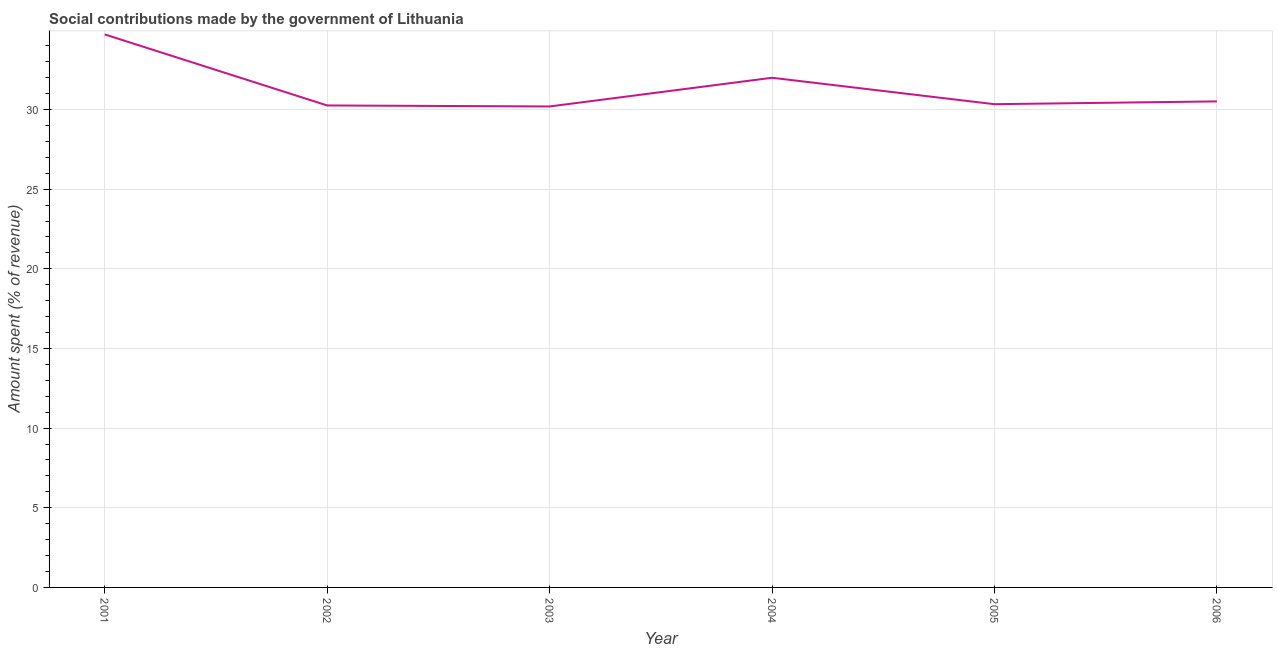What is the amount spent in making social contributions in 2001?
Ensure brevity in your answer.  34.71. Across all years, what is the maximum amount spent in making social contributions?
Ensure brevity in your answer.  34.71. Across all years, what is the minimum amount spent in making social contributions?
Make the answer very short. 30.19. In which year was the amount spent in making social contributions maximum?
Your answer should be compact. 2001. In which year was the amount spent in making social contributions minimum?
Give a very brief answer. 2003. What is the sum of the amount spent in making social contributions?
Offer a very short reply. 187.99. What is the difference between the amount spent in making social contributions in 2003 and 2005?
Offer a terse response. -0.14. What is the average amount spent in making social contributions per year?
Your response must be concise. 31.33. What is the median amount spent in making social contributions?
Provide a succinct answer. 30.42. In how many years, is the amount spent in making social contributions greater than 22 %?
Offer a very short reply. 6. What is the ratio of the amount spent in making social contributions in 2001 to that in 2003?
Keep it short and to the point. 1.15. What is the difference between the highest and the second highest amount spent in making social contributions?
Ensure brevity in your answer.  2.72. Is the sum of the amount spent in making social contributions in 2002 and 2006 greater than the maximum amount spent in making social contributions across all years?
Your answer should be compact. Yes. What is the difference between the highest and the lowest amount spent in making social contributions?
Make the answer very short. 4.52. How many lines are there?
Offer a terse response. 1. How many years are there in the graph?
Provide a succinct answer. 6. Are the values on the major ticks of Y-axis written in scientific E-notation?
Keep it short and to the point. No. Does the graph contain any zero values?
Offer a very short reply. No. Does the graph contain grids?
Your answer should be very brief. Yes. What is the title of the graph?
Provide a succinct answer. Social contributions made by the government of Lithuania. What is the label or title of the Y-axis?
Your answer should be compact. Amount spent (% of revenue). What is the Amount spent (% of revenue) in 2001?
Make the answer very short. 34.71. What is the Amount spent (% of revenue) of 2002?
Provide a succinct answer. 30.25. What is the Amount spent (% of revenue) of 2003?
Offer a terse response. 30.19. What is the Amount spent (% of revenue) of 2004?
Make the answer very short. 31.99. What is the Amount spent (% of revenue) of 2005?
Your response must be concise. 30.33. What is the Amount spent (% of revenue) in 2006?
Make the answer very short. 30.51. What is the difference between the Amount spent (% of revenue) in 2001 and 2002?
Provide a short and direct response. 4.46. What is the difference between the Amount spent (% of revenue) in 2001 and 2003?
Your response must be concise. 4.52. What is the difference between the Amount spent (% of revenue) in 2001 and 2004?
Keep it short and to the point. 2.72. What is the difference between the Amount spent (% of revenue) in 2001 and 2005?
Offer a very short reply. 4.38. What is the difference between the Amount spent (% of revenue) in 2001 and 2006?
Provide a short and direct response. 4.2. What is the difference between the Amount spent (% of revenue) in 2002 and 2003?
Offer a terse response. 0.06. What is the difference between the Amount spent (% of revenue) in 2002 and 2004?
Make the answer very short. -1.74. What is the difference between the Amount spent (% of revenue) in 2002 and 2005?
Offer a very short reply. -0.08. What is the difference between the Amount spent (% of revenue) in 2002 and 2006?
Ensure brevity in your answer.  -0.25. What is the difference between the Amount spent (% of revenue) in 2003 and 2004?
Your answer should be very brief. -1.8. What is the difference between the Amount spent (% of revenue) in 2003 and 2005?
Offer a very short reply. -0.14. What is the difference between the Amount spent (% of revenue) in 2003 and 2006?
Give a very brief answer. -0.32. What is the difference between the Amount spent (% of revenue) in 2004 and 2005?
Offer a very short reply. 1.66. What is the difference between the Amount spent (% of revenue) in 2004 and 2006?
Provide a short and direct response. 1.48. What is the difference between the Amount spent (% of revenue) in 2005 and 2006?
Your answer should be compact. -0.18. What is the ratio of the Amount spent (% of revenue) in 2001 to that in 2002?
Your response must be concise. 1.15. What is the ratio of the Amount spent (% of revenue) in 2001 to that in 2003?
Give a very brief answer. 1.15. What is the ratio of the Amount spent (% of revenue) in 2001 to that in 2004?
Your answer should be very brief. 1.08. What is the ratio of the Amount spent (% of revenue) in 2001 to that in 2005?
Your answer should be very brief. 1.14. What is the ratio of the Amount spent (% of revenue) in 2001 to that in 2006?
Your response must be concise. 1.14. What is the ratio of the Amount spent (% of revenue) in 2002 to that in 2004?
Make the answer very short. 0.95. What is the ratio of the Amount spent (% of revenue) in 2002 to that in 2005?
Keep it short and to the point. 1. What is the ratio of the Amount spent (% of revenue) in 2003 to that in 2004?
Your answer should be very brief. 0.94. What is the ratio of the Amount spent (% of revenue) in 2003 to that in 2005?
Make the answer very short. 0.99. What is the ratio of the Amount spent (% of revenue) in 2003 to that in 2006?
Your response must be concise. 0.99. What is the ratio of the Amount spent (% of revenue) in 2004 to that in 2005?
Provide a succinct answer. 1.05. What is the ratio of the Amount spent (% of revenue) in 2004 to that in 2006?
Keep it short and to the point. 1.05. What is the ratio of the Amount spent (% of revenue) in 2005 to that in 2006?
Your answer should be compact. 0.99. 